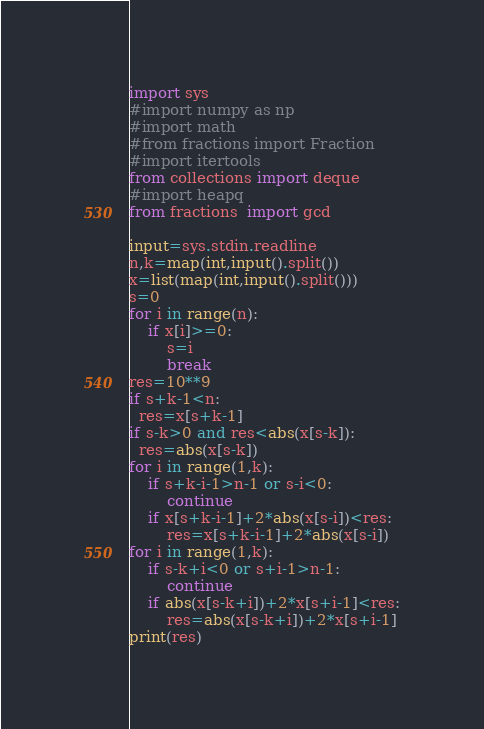Convert code to text. <code><loc_0><loc_0><loc_500><loc_500><_Python_>import sys
#import numpy as np
#import math
#from fractions import Fraction
#import itertools
from collections import deque
#import heapq
from fractions  import gcd

input=sys.stdin.readline
n,k=map(int,input().split())
x=list(map(int,input().split()))
s=0
for i in range(n):
    if x[i]>=0:
        s=i
        break
res=10**9
if s+k-1<n:
  res=x[s+k-1]
if s-k>0 and res<abs(x[s-k]):
  res=abs(x[s-k])
for i in range(1,k):
    if s+k-i-1>n-1 or s-i<0:
        continue
    if x[s+k-i-1]+2*abs(x[s-i])<res:
        res=x[s+k-i-1]+2*abs(x[s-i])
for i in range(1,k):
    if s-k+i<0 or s+i-1>n-1:
        continue
    if abs(x[s-k+i])+2*x[s+i-1]<res:
        res=abs(x[s-k+i])+2*x[s+i-1]
print(res)
</code> 